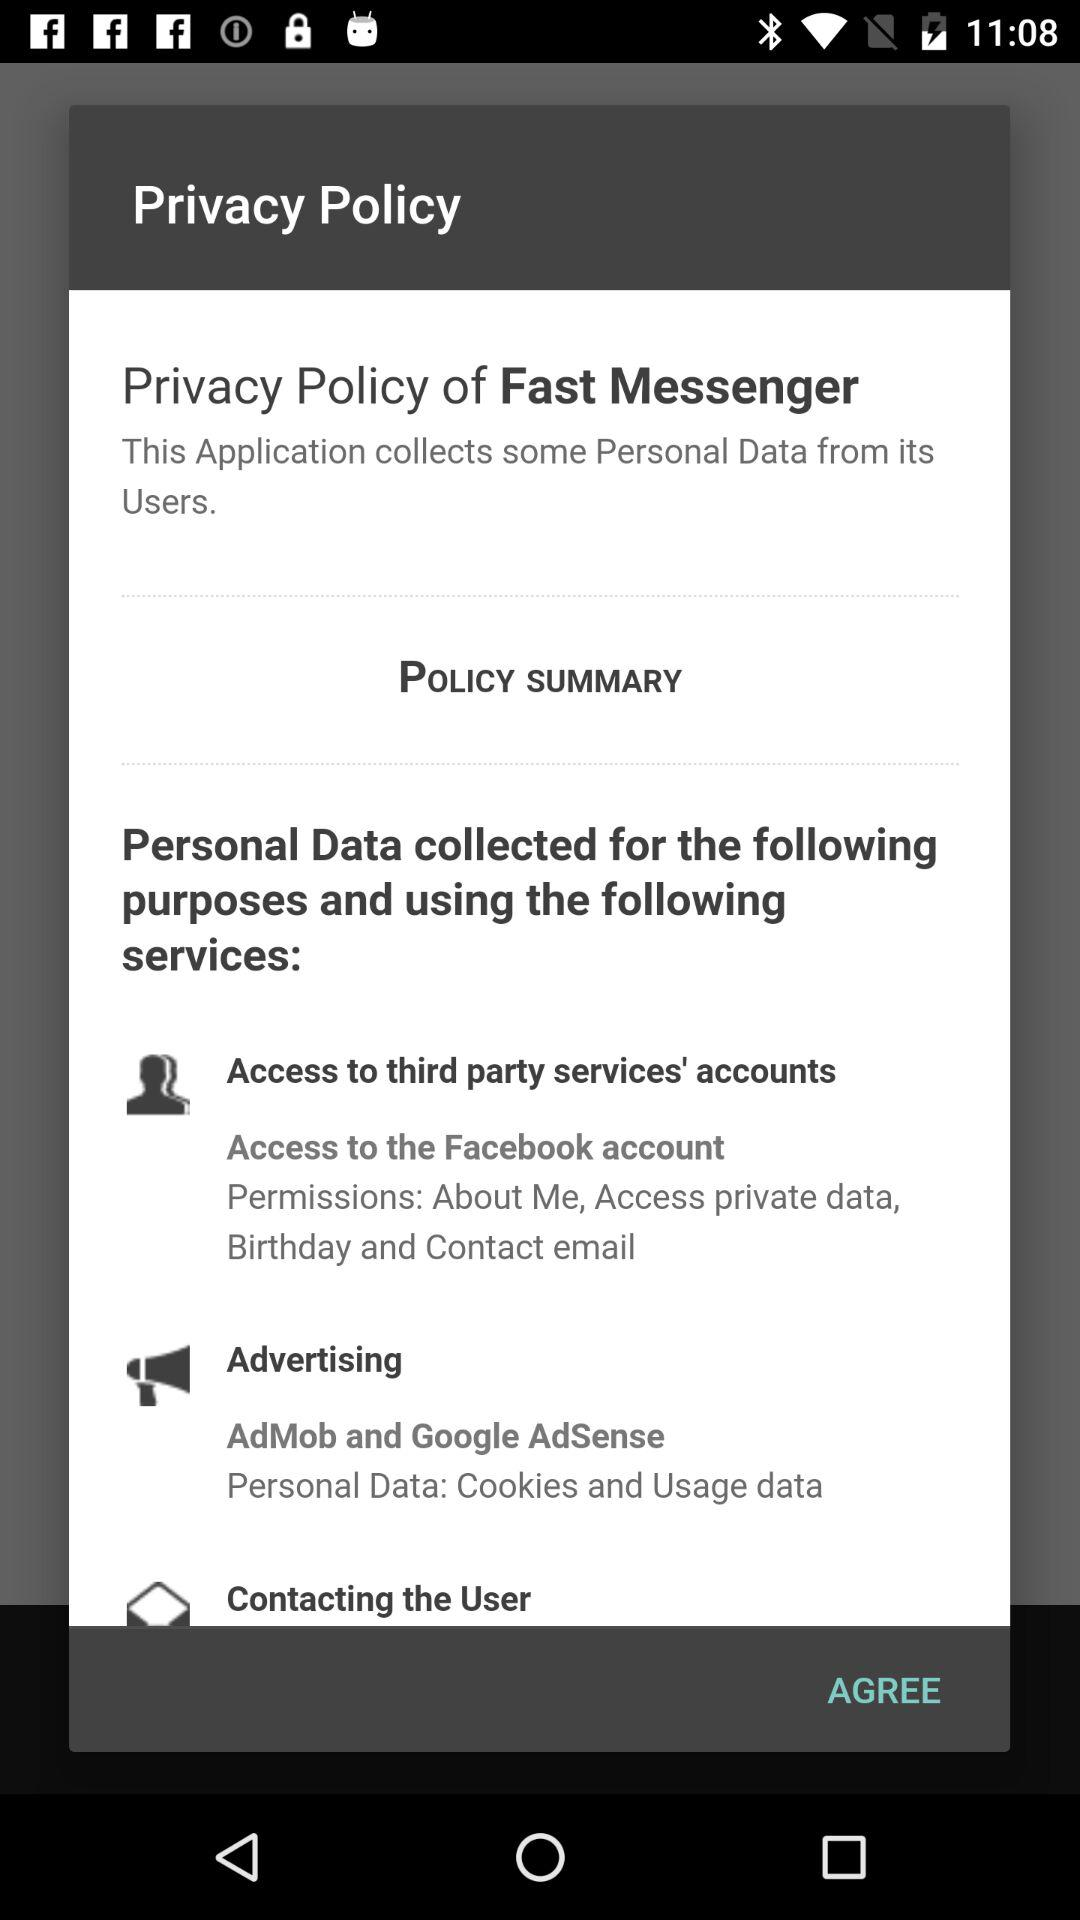What is the name of the application? The name of the application is "Fast Messenger". 